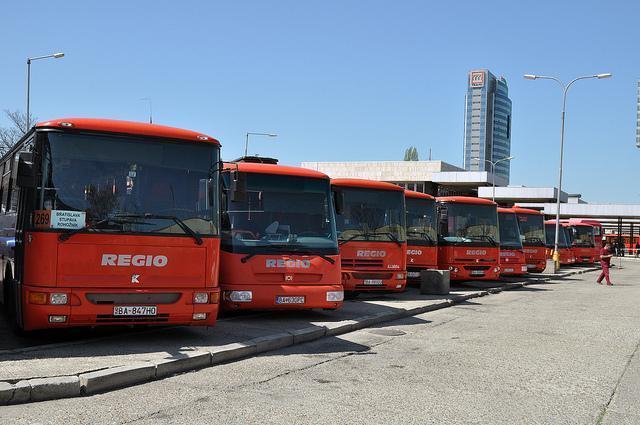How many red and white trucks are there?
Give a very brief answer. 10. How many buses are there?
Give a very brief answer. 5. 